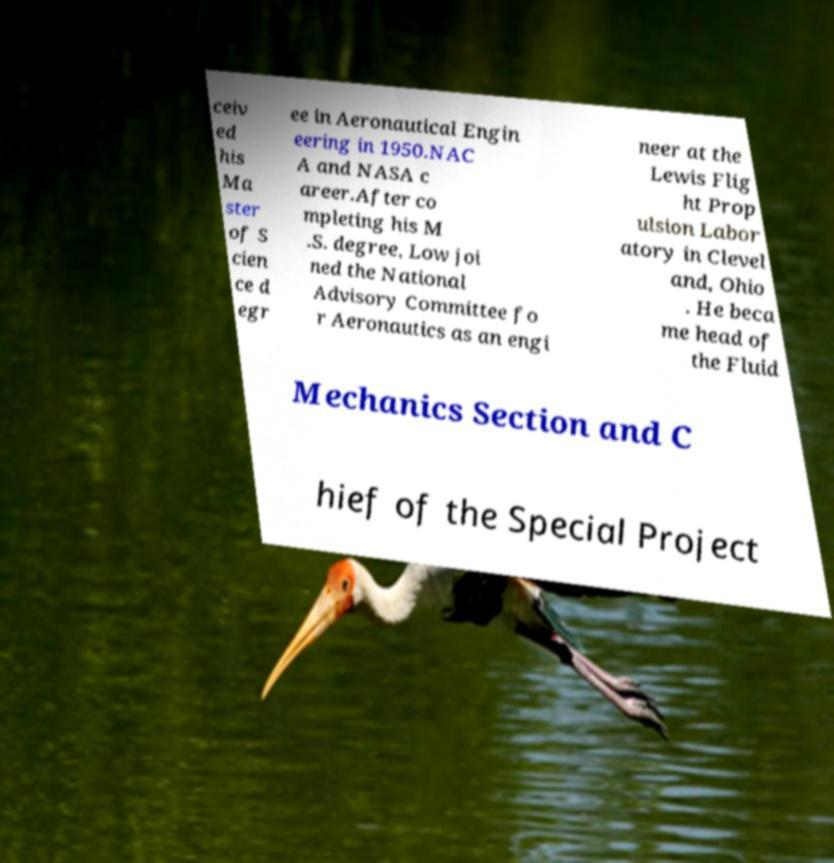What messages or text are displayed in this image? I need them in a readable, typed format. ceiv ed his Ma ster of S cien ce d egr ee in Aeronautical Engin eering in 1950.NAC A and NASA c areer.After co mpleting his M .S. degree, Low joi ned the National Advisory Committee fo r Aeronautics as an engi neer at the Lewis Flig ht Prop ulsion Labor atory in Clevel and, Ohio . He beca me head of the Fluid Mechanics Section and C hief of the Special Project 